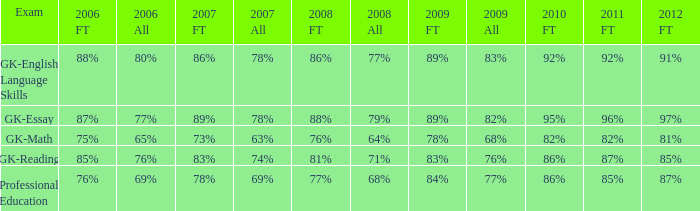What is the percentage for all in 2008 when all in 2007 was 69%? 68%. 